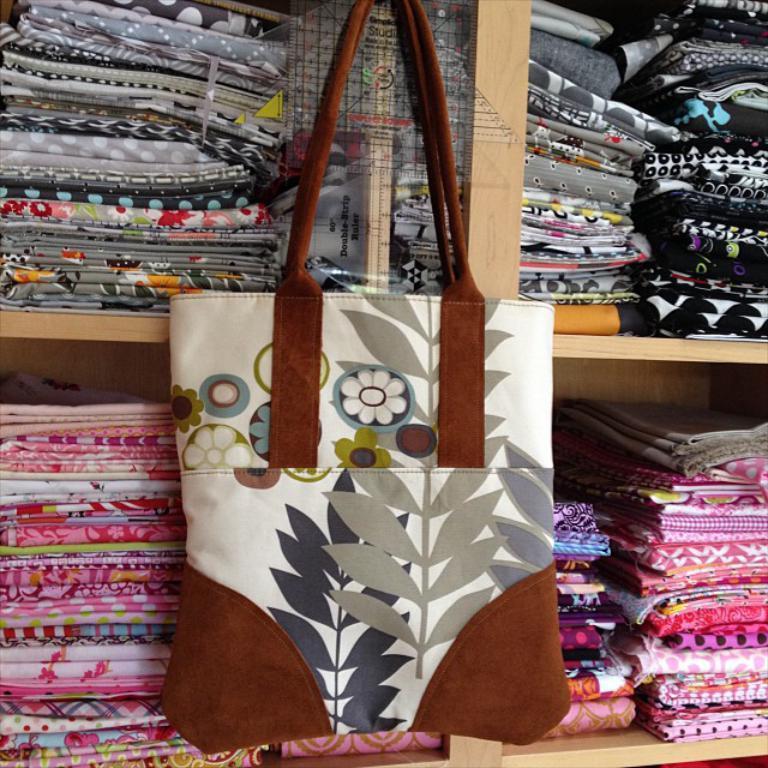Can you describe this image briefly? In the picture we can find racks with clothes and one hand bag just hanged to it. 